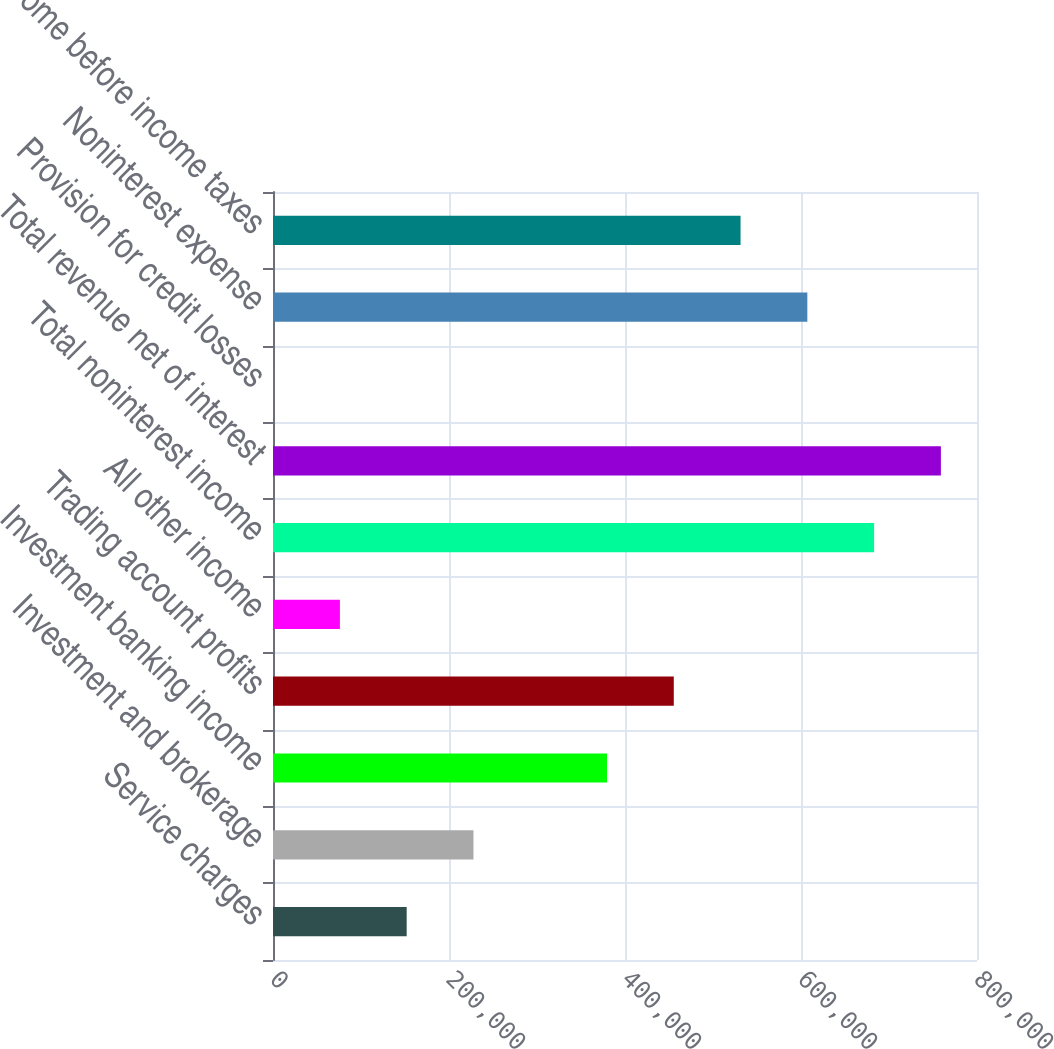Convert chart to OTSL. <chart><loc_0><loc_0><loc_500><loc_500><bar_chart><fcel>Service charges<fcel>Investment and brokerage<fcel>Investment banking income<fcel>Trading account profits<fcel>All other income<fcel>Total noninterest income<fcel>Total revenue net of interest<fcel>Provision for credit losses<fcel>Noninterest expense<fcel>Income before income taxes<nl><fcel>151916<fcel>227796<fcel>379556<fcel>455437<fcel>76035.3<fcel>683078<fcel>758958<fcel>155<fcel>607197<fcel>531317<nl></chart> 